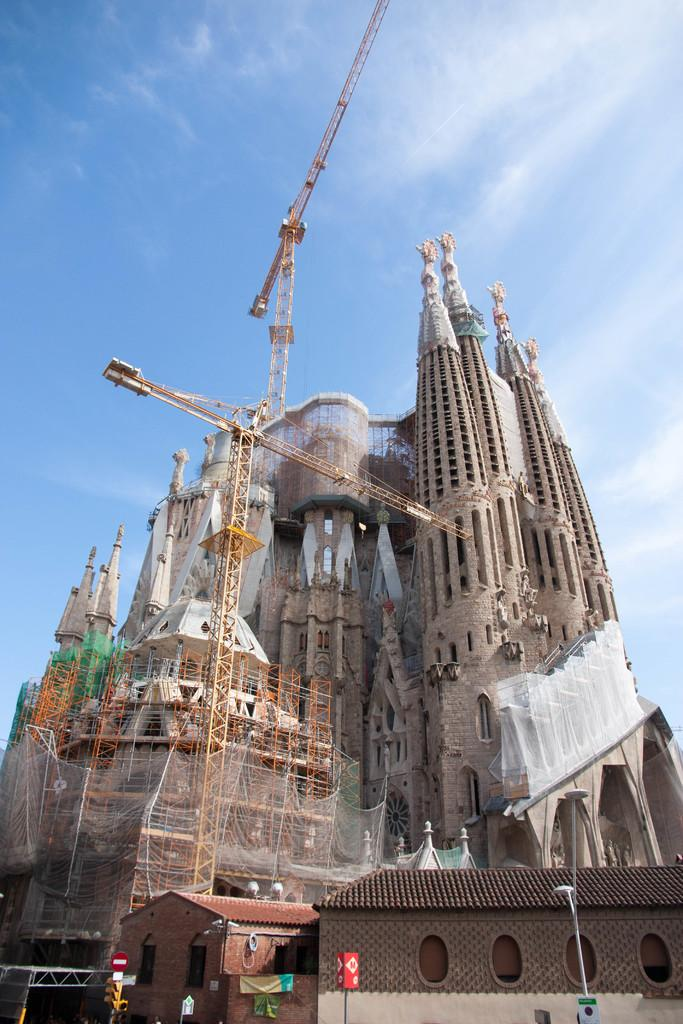What type of structure is present in the image? There is a fort in the image. What other type of structure can be seen in the image? There is a building in the image. What piece of machinery is visible in the image? A crane is visible in the image. What are the poles used for in the image? The purpose of the poles in the image is not specified, but they are likely used for support or as part of a fence or barrier. What is visible at the top of the image? The sky is visible at the top of the image. What type of competition is taking place in the image? There is no competition present in the image. What type of truck can be seen in the image? There is no truck present in the image. 